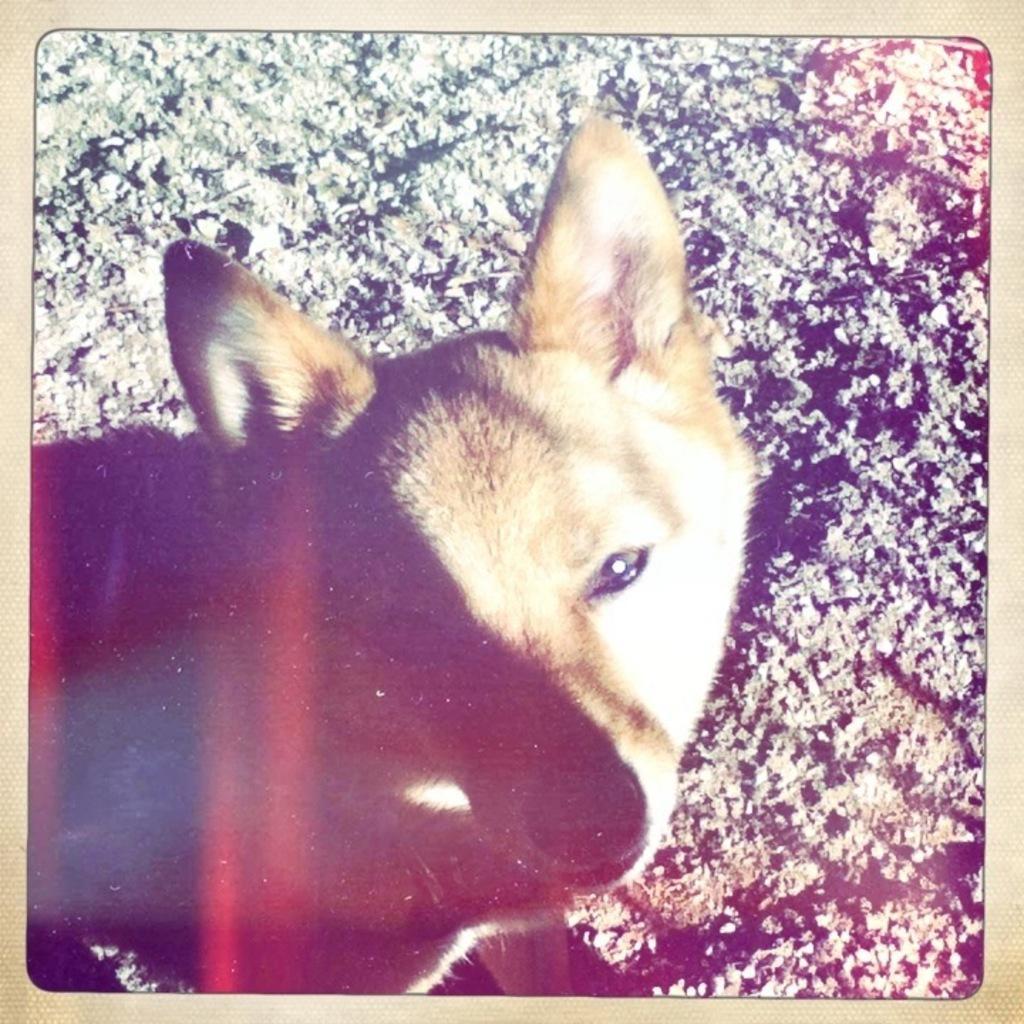Could you give a brief overview of what you see in this image? In this image we can see a photograph on a page of the album and in the photo we can see a dog and stones on the ground. 